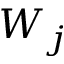<formula> <loc_0><loc_0><loc_500><loc_500>W _ { j }</formula> 